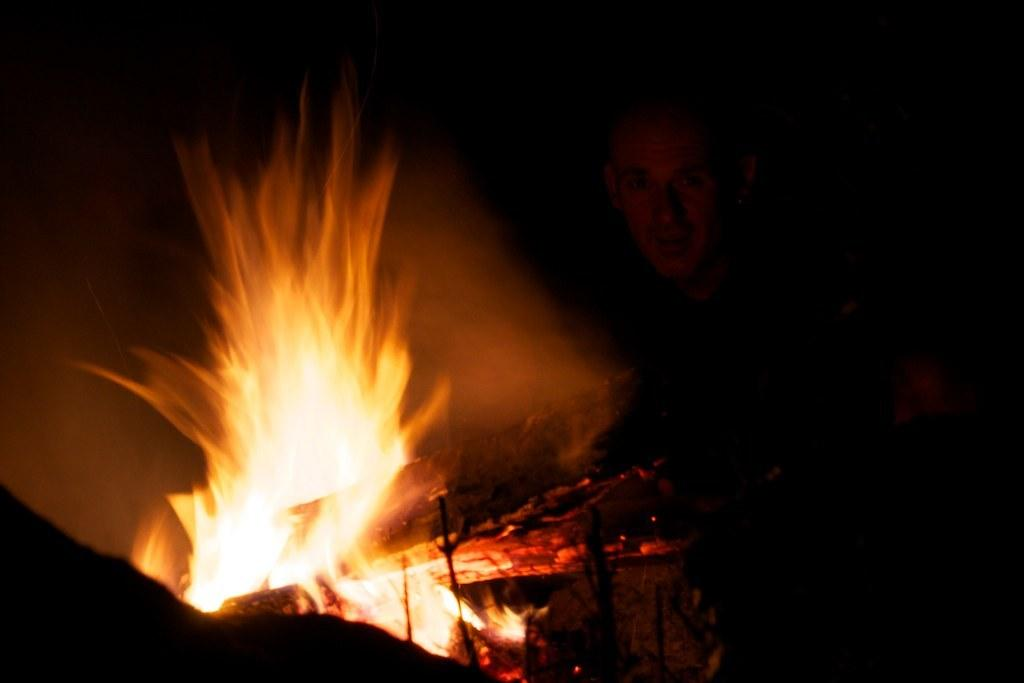Who is present in the image? There is a person in the image. What is the person doing or standing near in the image? The person is behind a fire camp. What type of stone can be seen at the airport in the image? There is no airport or stone present in the image; it features a person behind a fire camp. 